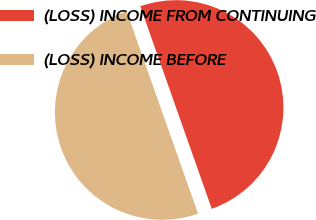<chart> <loc_0><loc_0><loc_500><loc_500><pie_chart><fcel>(LOSS) INCOME FROM CONTINUING<fcel>(LOSS) INCOME BEFORE<nl><fcel>50.0%<fcel>50.0%<nl></chart> 